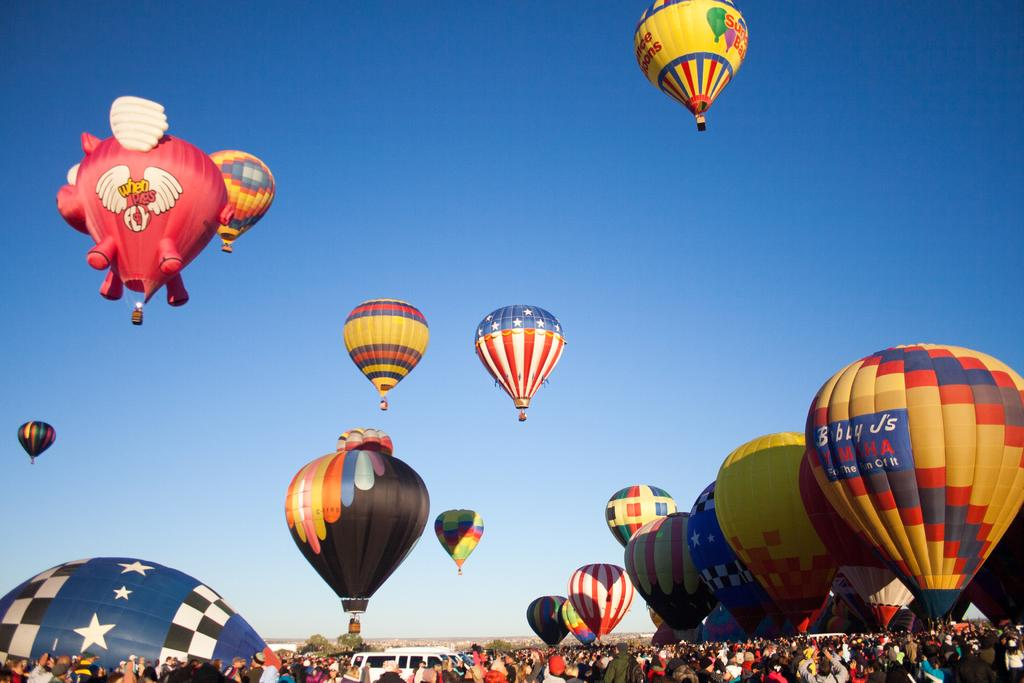<image>
Share a concise interpretation of the image provided. A variety of hot air balloons and one sponsored by Bobby J's Yamaha 